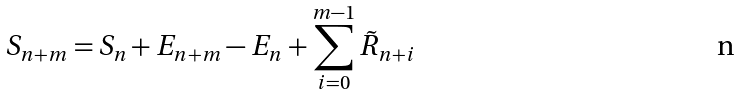Convert formula to latex. <formula><loc_0><loc_0><loc_500><loc_500>S _ { n + m } = S _ { n } + E _ { n + m } - E _ { n } + \sum _ { i = 0 } ^ { m - 1 } \tilde { R } _ { n + i }</formula> 